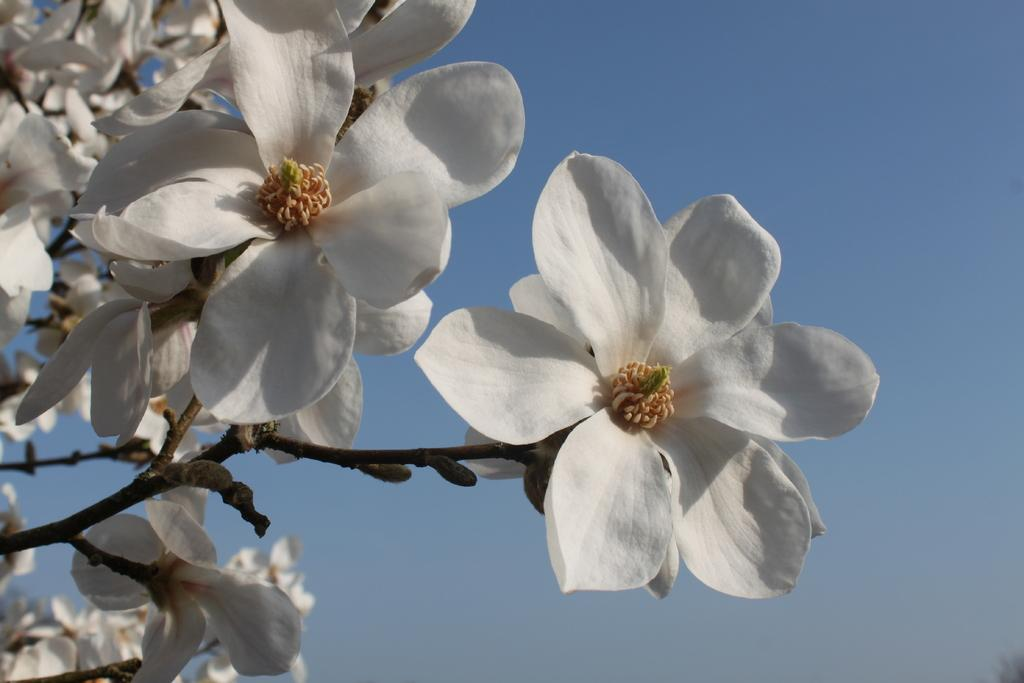What type of plant life is visible in the image? There are flowers and stems of a tree in the image. What is the condition of the sky in the image? The sky is clear in the image. What is the weather like in the image? It is sunny in the image. What is the position of the bean in the image? There is no bean present in the image. How many passengers are visible in the image? There are no passengers visible in the image. 